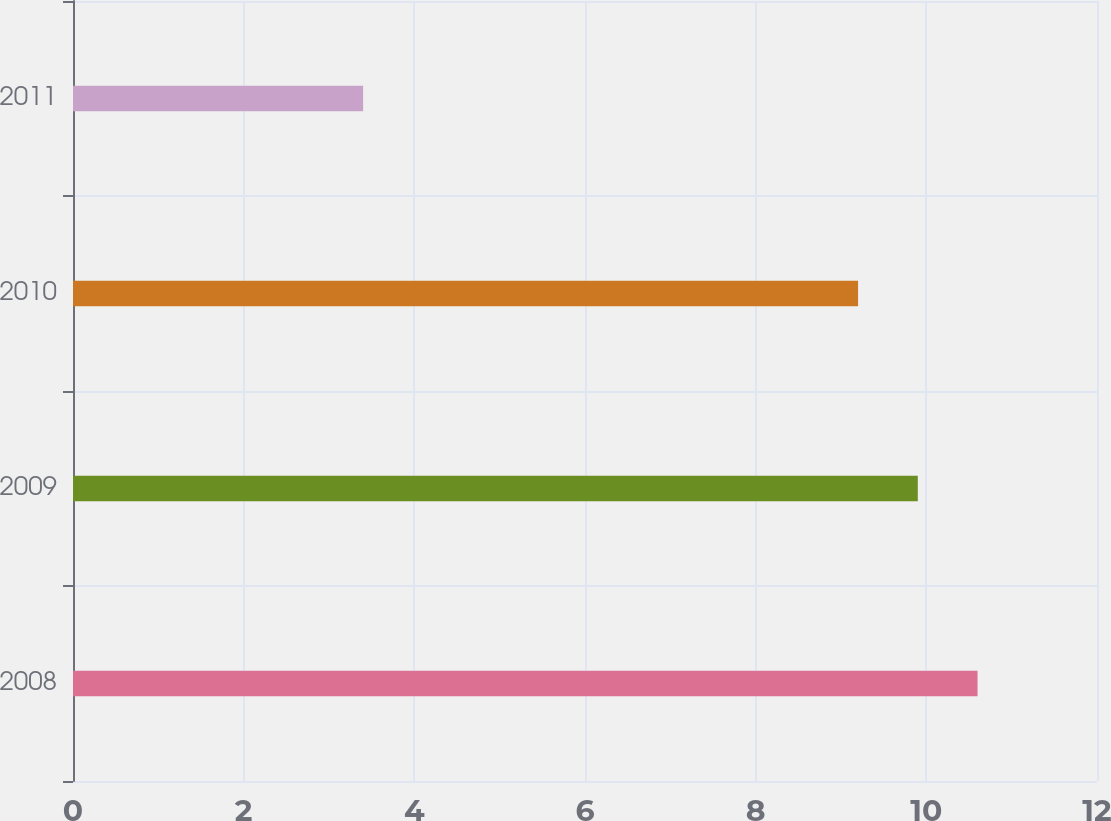Convert chart. <chart><loc_0><loc_0><loc_500><loc_500><bar_chart><fcel>2008<fcel>2009<fcel>2010<fcel>2011<nl><fcel>10.6<fcel>9.9<fcel>9.2<fcel>3.4<nl></chart> 